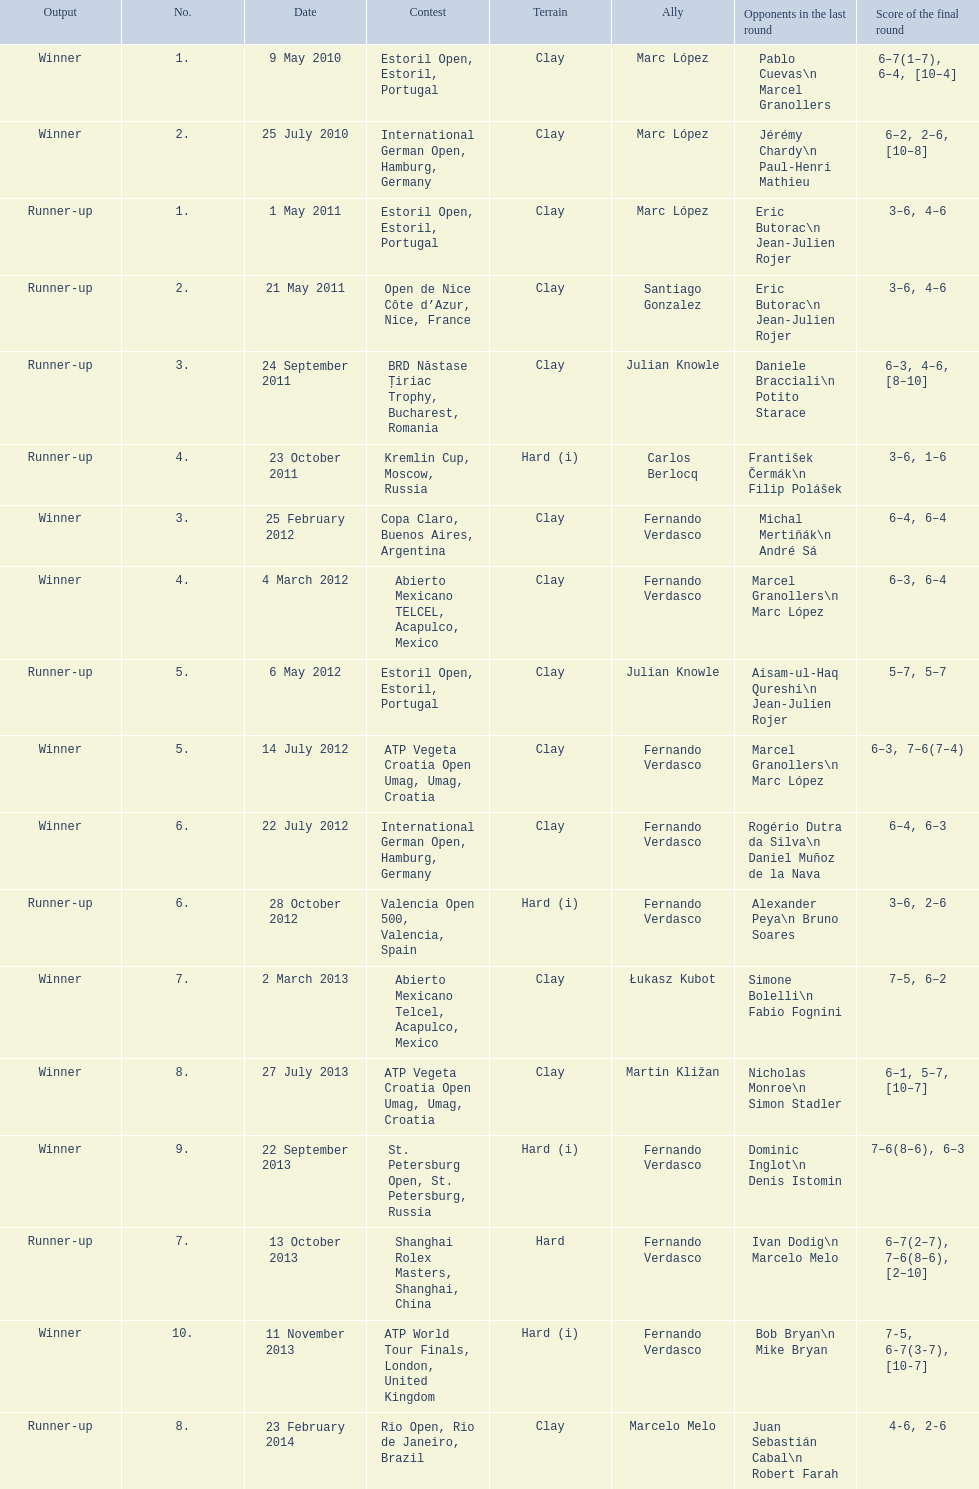What event was held subsequent to the kremlin cup? Copa Claro, Buenos Aires, Argentina. 